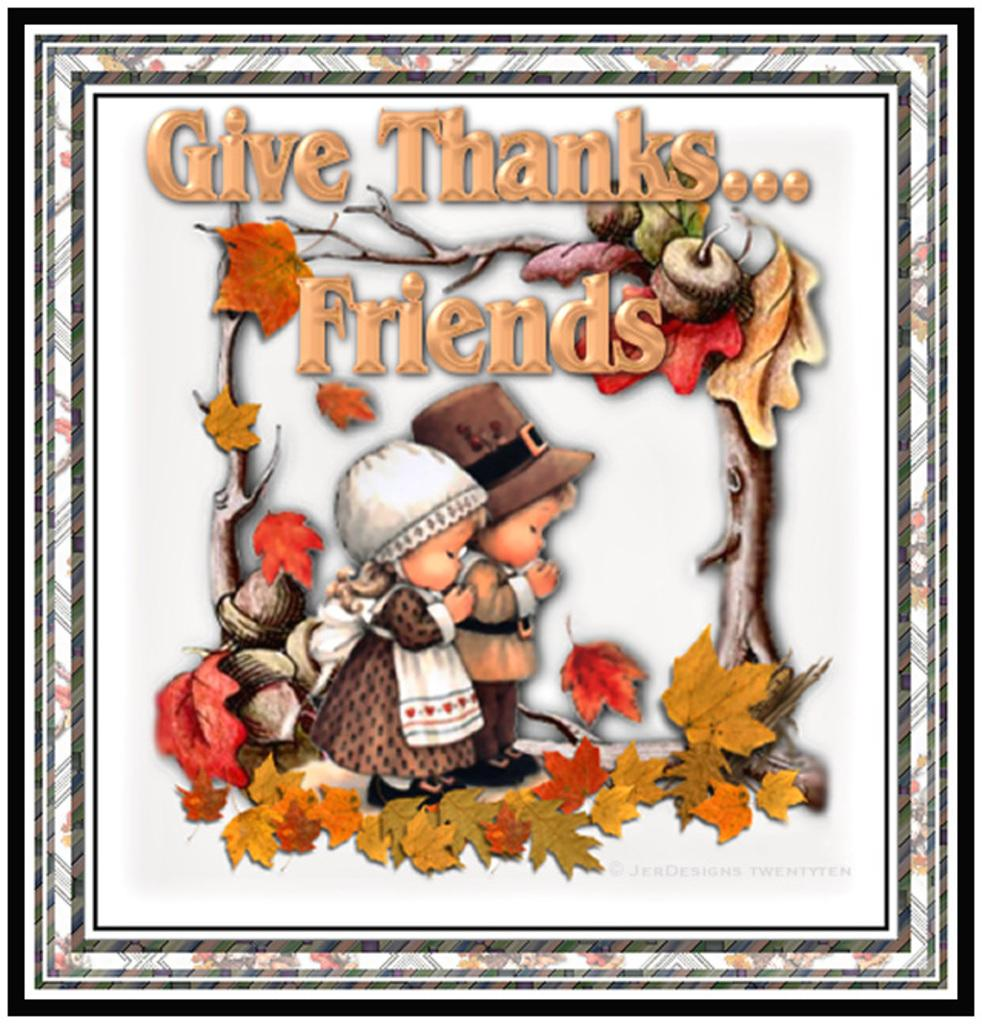What is the main subject of the image? The main subject of the image is a frame with a painting. What can be seen in the painting? The painting contains two persons, leaves, branches, fruits, and text. Can you describe the setting of the painting? The painting includes leaves, branches, and fruits, which suggests a natural setting. What type of liquid can be seen flowing through the machine in the image? There is no machine or liquid present in the image; it features a frame with a painting. 